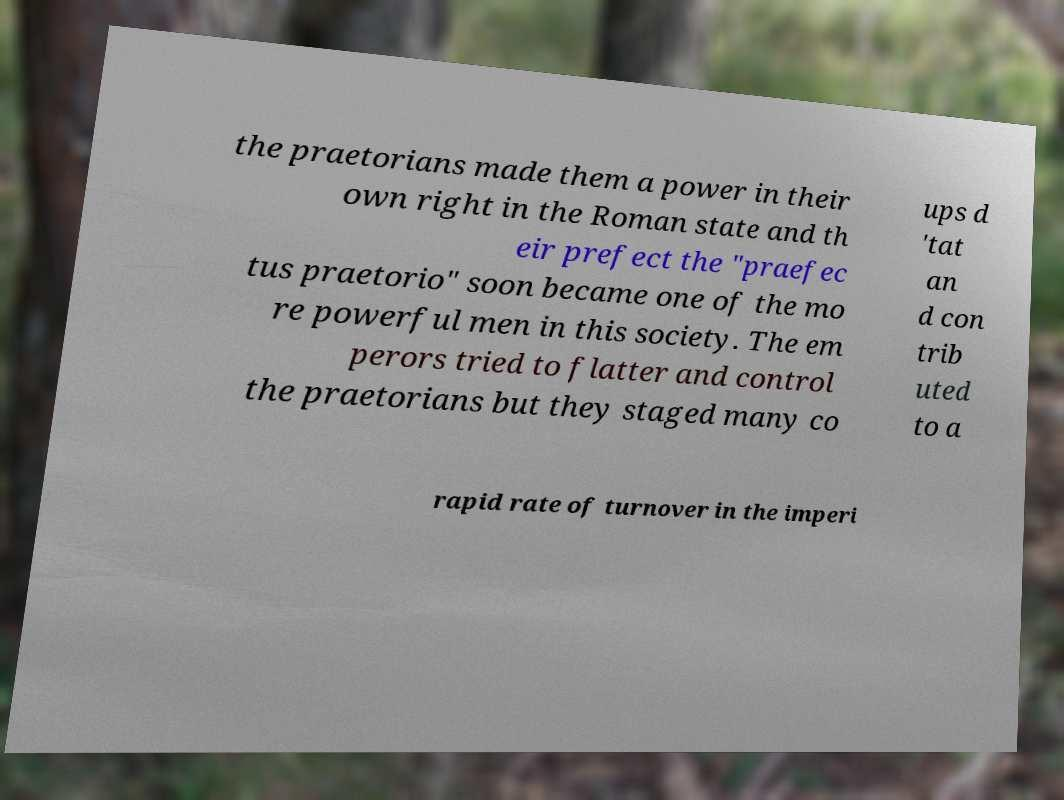Could you assist in decoding the text presented in this image and type it out clearly? the praetorians made them a power in their own right in the Roman state and th eir prefect the "praefec tus praetorio" soon became one of the mo re powerful men in this society. The em perors tried to flatter and control the praetorians but they staged many co ups d 'tat an d con trib uted to a rapid rate of turnover in the imperi 